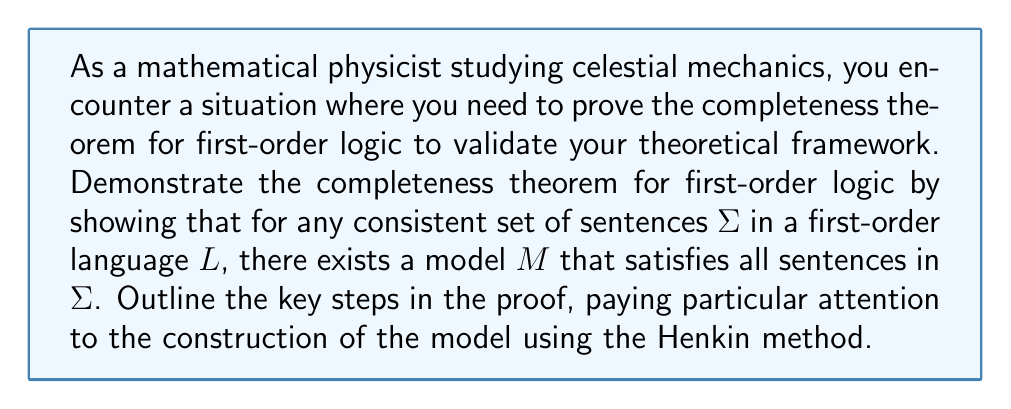Could you help me with this problem? To prove the completeness theorem for first-order logic, we will follow these key steps:

1. Start with a consistent set of sentences $\Sigma$ in a first-order language $L$.

2. Extend $L$ to a new language $L'$ by adding countably many new constant symbols $c_1, c_2, c_3, \ldots$.

3. Construct a maximally consistent set of sentences $\Sigma'$ in $L'$ that extends $\Sigma$:

   a) Enumerate all sentences of $L'$: $\phi_1, \phi_2, \phi_3, \ldots$
   b) Define $\Sigma_0 = \Sigma$
   c) For each $n \geq 1$, define $\Sigma_n$ as follows:
      - If $\Sigma_{n-1} \cup \{\phi_n\}$ is consistent, let $\Sigma_n = \Sigma_{n-1} \cup \{\phi_n\}$
      - If $\Sigma_{n-1} \cup \{\phi_n\}$ is inconsistent, let $\Sigma_n = \Sigma_{n-1}$
   d) Define $\Sigma' = \bigcup_{n=0}^{\infty} \Sigma_n$

4. Prove that $\Sigma'$ has the following properties:
   - Consistency: $\Sigma'$ is consistent
   - Maximality: For any sentence $\phi$ in $L'$, either $\phi \in \Sigma'$ or $\neg\phi \in \Sigma'$
   - Henkin property: For any formula $\exists x \psi(x)$ in $\Sigma'$, there exists a constant $c$ such that $\psi(c) \in \Sigma'$

5. Construct a model $M$ for $\Sigma'$:
   - Define the domain $D$ as the set of all constant symbols in $L'$
   - For each n-ary predicate symbol $P$ in $L'$, define $P^M \subseteq D^n$ as:
     $P^M = \{(c_1, \ldots, c_n) \in D^n : P(c_1, \ldots, c_n) \in \Sigma'\}$
   - For each n-ary function symbol $f$ in $L'$, define $f^M: D^n \to D$ as:
     $f^M(c_1, \ldots, c_n) = c$, where $f(c_1, \ldots, c_n) = c \in \Sigma'$
   - For each constant symbol $c$ in $L'$, define $c^M = c$

6. Prove the Truth Lemma: For any formula $\phi(x_1, \ldots, x_n)$ in $L'$ and any constants $c_1, \ldots, c_n$:
   $M \models \phi(c_1, \ldots, c_n)$ if and only if $\phi(c_1, \ldots, c_n) \in \Sigma'$

7. Conclude that $M$ is a model of $\Sigma$, as $\Sigma \subseteq \Sigma'$ and $M \models \Sigma'$.

This proof demonstrates that any consistent set of sentences in first-order logic has a model, which is the essence of the completeness theorem.
Answer: The completeness theorem for first-order logic is proved by constructing a model $M$ for any consistent set of sentences $\Sigma$ using the Henkin method. The key steps involve extending the language, creating a maximally consistent set of sentences, and constructing a model based on this set. The Truth Lemma establishes that the constructed model satisfies all sentences in the original set $\Sigma$, thus proving the completeness theorem. 